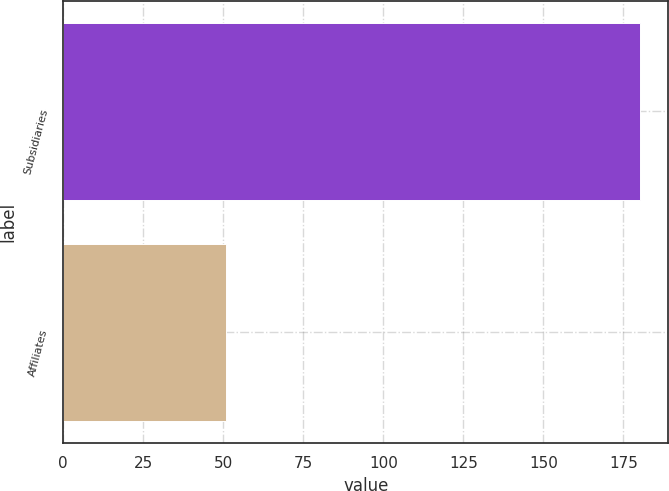Convert chart to OTSL. <chart><loc_0><loc_0><loc_500><loc_500><bar_chart><fcel>Subsidiaries<fcel>Affiliates<nl><fcel>180<fcel>51<nl></chart> 